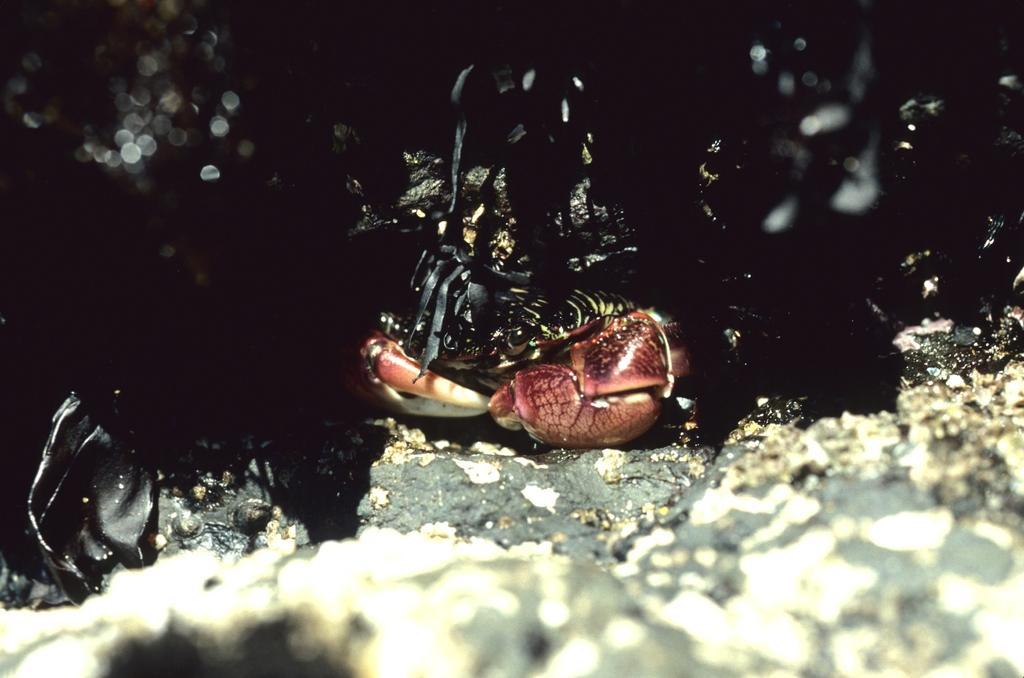In one or two sentences, can you explain what this image depicts? This image consists of an animal. It is in black color. 